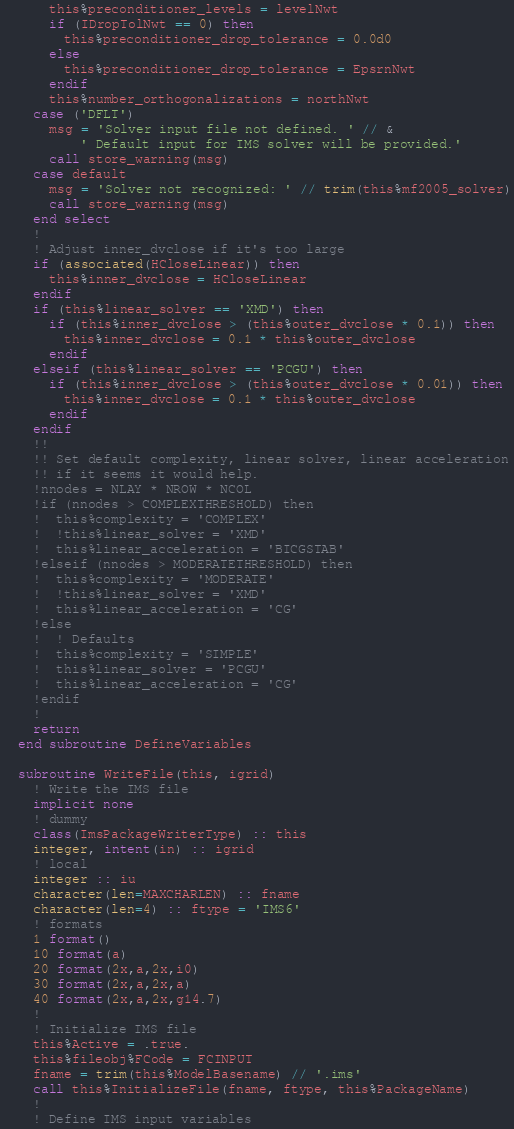Convert code to text. <code><loc_0><loc_0><loc_500><loc_500><_FORTRAN_>      this%preconditioner_levels = levelNwt
      if (IDropTolNwt == 0) then
        this%preconditioner_drop_tolerance = 0.0d0
      else
        this%preconditioner_drop_tolerance = EpsrnNwt
      endif
      this%number_orthogonalizations = northNwt
    case ('DFLT')
      msg = 'Solver input file not defined. ' // &
          ' Default input for IMS solver will be provided.'
      call store_warning(msg)
    case default
      msg = 'Solver not recognized: ' // trim(this%mf2005_solver)
      call store_warning(msg)
    end select
    !
    ! Adjust inner_dvclose if it's too large
    if (associated(HCloseLinear)) then
      this%inner_dvclose = HCloseLinear
    endif
    if (this%linear_solver == 'XMD') then
      if (this%inner_dvclose > (this%outer_dvclose * 0.1)) then
        this%inner_dvclose = 0.1 * this%outer_dvclose
      endif
    elseif (this%linear_solver == 'PCGU') then
      if (this%inner_dvclose > (this%outer_dvclose * 0.01)) then
        this%inner_dvclose = 0.1 * this%outer_dvclose
      endif
    endif
    !!
    !! Set default complexity, linear solver, linear acceleration
    !! if it seems it would help.
    !nnodes = NLAY * NROW * NCOL
    !if (nnodes > COMPLEXTHRESHOLD) then
    !  this%complexity = 'COMPLEX'
    !  !this%linear_solver = 'XMD'
    !  this%linear_acceleration = 'BICGSTAB'
    !elseif (nnodes > MODERATETHRESHOLD) then
    !  this%complexity = 'MODERATE'
    !  !this%linear_solver = 'XMD'
    !  this%linear_acceleration = 'CG'
    !else
    !  ! Defaults
    !  this%complexity = 'SIMPLE'
    !  this%linear_solver = 'PCGU'
    !  this%linear_acceleration = 'CG'
    !endif
    !
    return
  end subroutine DefineVariables

  subroutine WriteFile(this, igrid)
    ! Write the IMS file
    implicit none
    ! dummy
    class(ImsPackageWriterType) :: this
    integer, intent(in) :: igrid
    ! local
    integer :: iu
    character(len=MAXCHARLEN) :: fname
    character(len=4) :: ftype = 'IMS6'
    ! formats
    1 format()
    10 format(a)
    20 format(2x,a,2x,i0)
    30 format(2x,a,2x,a)
    40 format(2x,a,2x,g14.7)
    !
    ! Initialize IMS file
    this%Active = .true.
    this%fileobj%FCode = FCINPUT
    fname = trim(this%ModelBasename) // '.ims'
    call this%InitializeFile(fname, ftype, this%PackageName)
    !
    ! Define IMS input variables</code> 